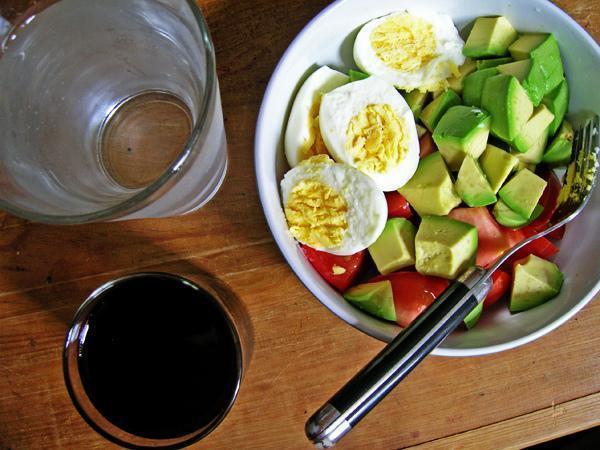How many carrots is there?
Give a very brief answer. 0. How many egg halves?
Give a very brief answer. 4. How many cups are there?
Give a very brief answer. 2. 